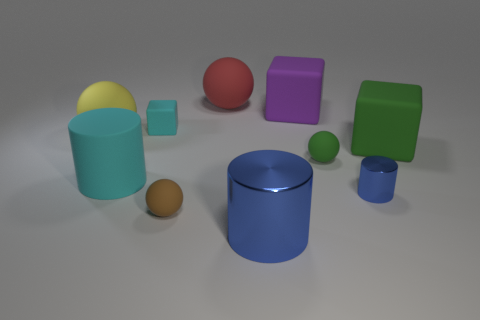How many small matte things are both to the left of the big blue shiny thing and right of the big metallic thing?
Keep it short and to the point. 0. What is the shape of the big cyan object that is the same material as the big red sphere?
Give a very brief answer. Cylinder. There is a cyan matte object that is in front of the yellow ball; is it the same size as the rubber object on the right side of the tiny blue metallic thing?
Keep it short and to the point. Yes. The large rubber object that is in front of the green cube is what color?
Your answer should be compact. Cyan. The ball in front of the cyan matte thing in front of the yellow rubber sphere is made of what material?
Provide a succinct answer. Rubber. What shape is the big blue shiny thing?
Provide a succinct answer. Cylinder. There is a small blue thing that is the same shape as the large cyan rubber thing; what material is it?
Give a very brief answer. Metal. What number of green cubes are the same size as the red matte thing?
Your answer should be compact. 1. There is a cyan matte thing that is in front of the small cyan rubber thing; is there a cyan matte cylinder on the left side of it?
Your answer should be compact. No. How many purple objects are either large cylinders or big rubber things?
Your answer should be very brief. 1. 